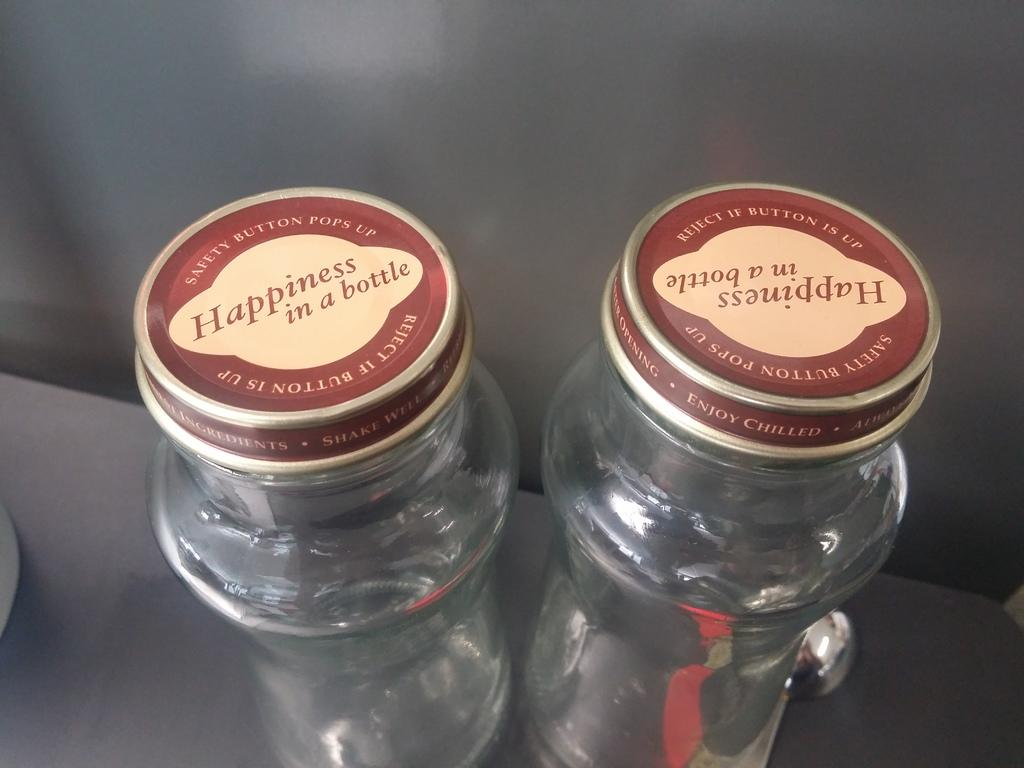<image>
Describe the image concisely. Two small glass bottles have metal lids that say Happiness in a bottle. 